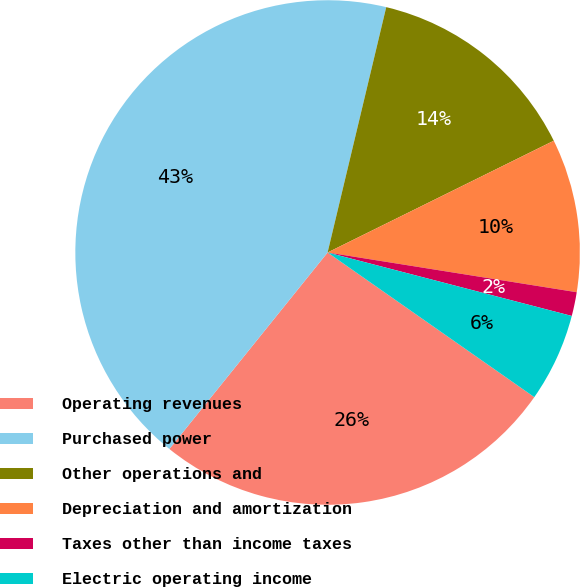Convert chart. <chart><loc_0><loc_0><loc_500><loc_500><pie_chart><fcel>Operating revenues<fcel>Purchased power<fcel>Other operations and<fcel>Depreciation and amortization<fcel>Taxes other than income taxes<fcel>Electric operating income<nl><fcel>26.07%<fcel>42.94%<fcel>13.96%<fcel>9.82%<fcel>1.53%<fcel>5.67%<nl></chart> 